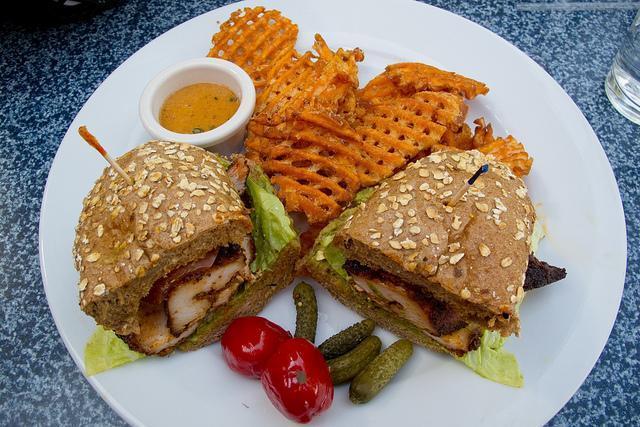How many sandwiches can you see?
Give a very brief answer. 2. 